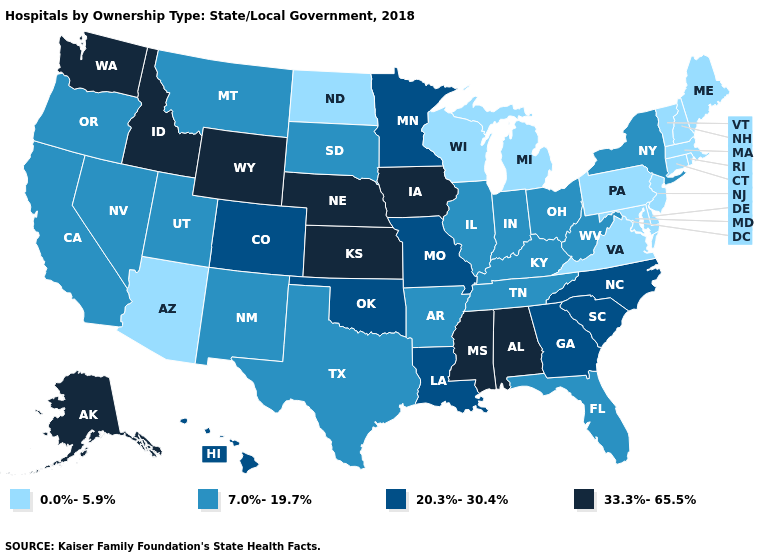Among the states that border Pennsylvania , does New Jersey have the highest value?
Concise answer only. No. What is the value of Wyoming?
Answer briefly. 33.3%-65.5%. What is the lowest value in the West?
Short answer required. 0.0%-5.9%. Does Hawaii have the highest value in the West?
Short answer required. No. Does New Hampshire have a lower value than Maine?
Short answer required. No. Is the legend a continuous bar?
Concise answer only. No. Does the first symbol in the legend represent the smallest category?
Short answer required. Yes. Which states have the lowest value in the West?
Write a very short answer. Arizona. How many symbols are there in the legend?
Quick response, please. 4. Among the states that border Colorado , does New Mexico have the highest value?
Give a very brief answer. No. Which states have the lowest value in the USA?
Short answer required. Arizona, Connecticut, Delaware, Maine, Maryland, Massachusetts, Michigan, New Hampshire, New Jersey, North Dakota, Pennsylvania, Rhode Island, Vermont, Virginia, Wisconsin. Does Vermont have the highest value in the Northeast?
Give a very brief answer. No. What is the value of Nebraska?
Give a very brief answer. 33.3%-65.5%. Name the states that have a value in the range 20.3%-30.4%?
Give a very brief answer. Colorado, Georgia, Hawaii, Louisiana, Minnesota, Missouri, North Carolina, Oklahoma, South Carolina. What is the value of Arizona?
Give a very brief answer. 0.0%-5.9%. 